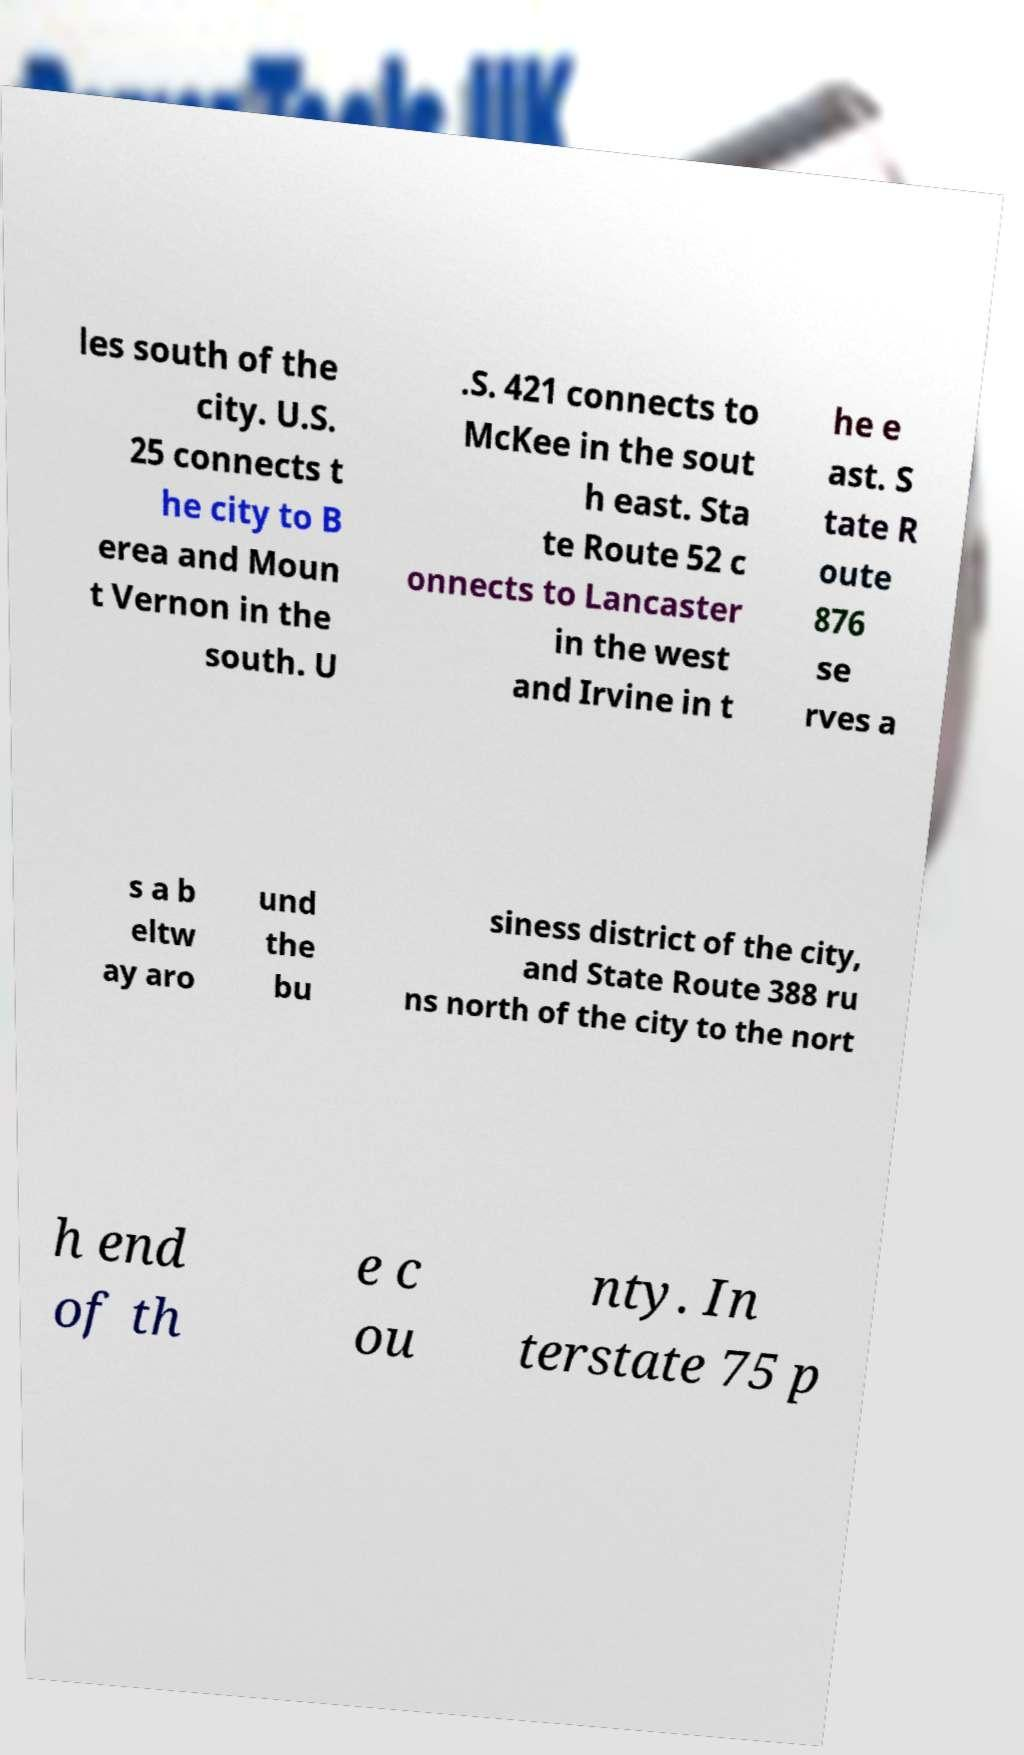Please read and relay the text visible in this image. What does it say? les south of the city. U.S. 25 connects t he city to B erea and Moun t Vernon in the south. U .S. 421 connects to McKee in the sout h east. Sta te Route 52 c onnects to Lancaster in the west and Irvine in t he e ast. S tate R oute 876 se rves a s a b eltw ay aro und the bu siness district of the city, and State Route 388 ru ns north of the city to the nort h end of th e c ou nty. In terstate 75 p 